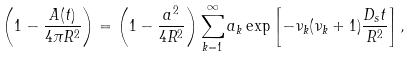Convert formula to latex. <formula><loc_0><loc_0><loc_500><loc_500>\left ( 1 - \frac { A ( t ) } { 4 \pi R ^ { 2 } } \right ) = \left ( 1 - \frac { a ^ { 2 } } { 4 R ^ { 2 } } \right ) \sum _ { k = 1 } ^ { \infty } a _ { k } \exp \left [ - \nu _ { k } ( \nu _ { k } + 1 ) \frac { D _ { s } t } { R ^ { 2 } } \right ] ,</formula> 